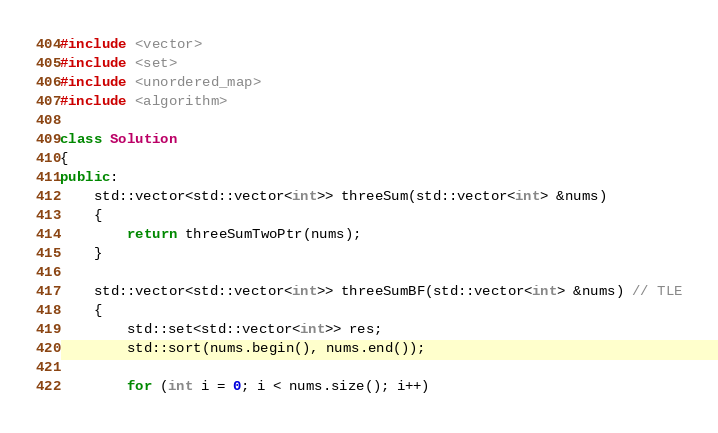<code> <loc_0><loc_0><loc_500><loc_500><_C++_>#include <vector>
#include <set>
#include <unordered_map>
#include <algorithm>

class Solution
{
public:
    std::vector<std::vector<int>> threeSum(std::vector<int> &nums)
    {
        return threeSumTwoPtr(nums);
    }

    std::vector<std::vector<int>> threeSumBF(std::vector<int> &nums) // TLE
    {
        std::set<std::vector<int>> res;
        std::sort(nums.begin(), nums.end());

        for (int i = 0; i < nums.size(); i++)</code> 